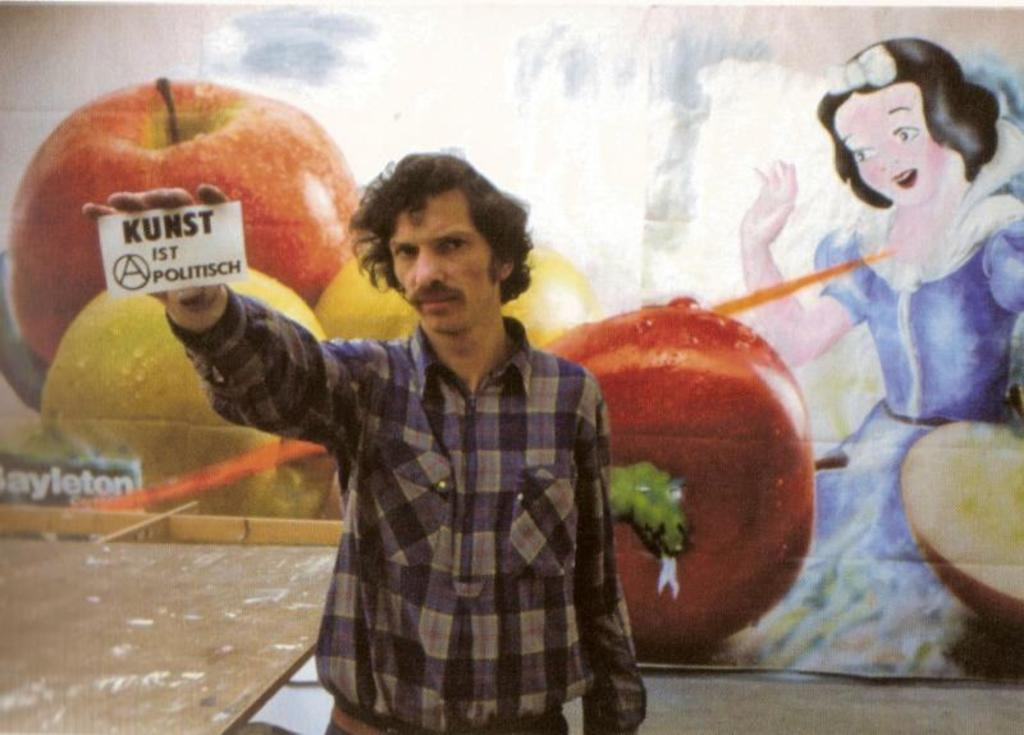What is the man in the image doing? The man is standing in the image and holding a board. What can be seen in the man's hands? The man is holding a wooden object, which appears to be a board. What is visible on the walls in the background of the image? There are paintings of fruits and a painting of a girl on the walls in the background. What type of haircut does the girl in the painting have? There is no girl present in the image; the question refers to a painting of a girl on the wall in the background. What type of fruit is the man eating in the image? There is no fruit visible in the image; the man is holding a wooden board. 